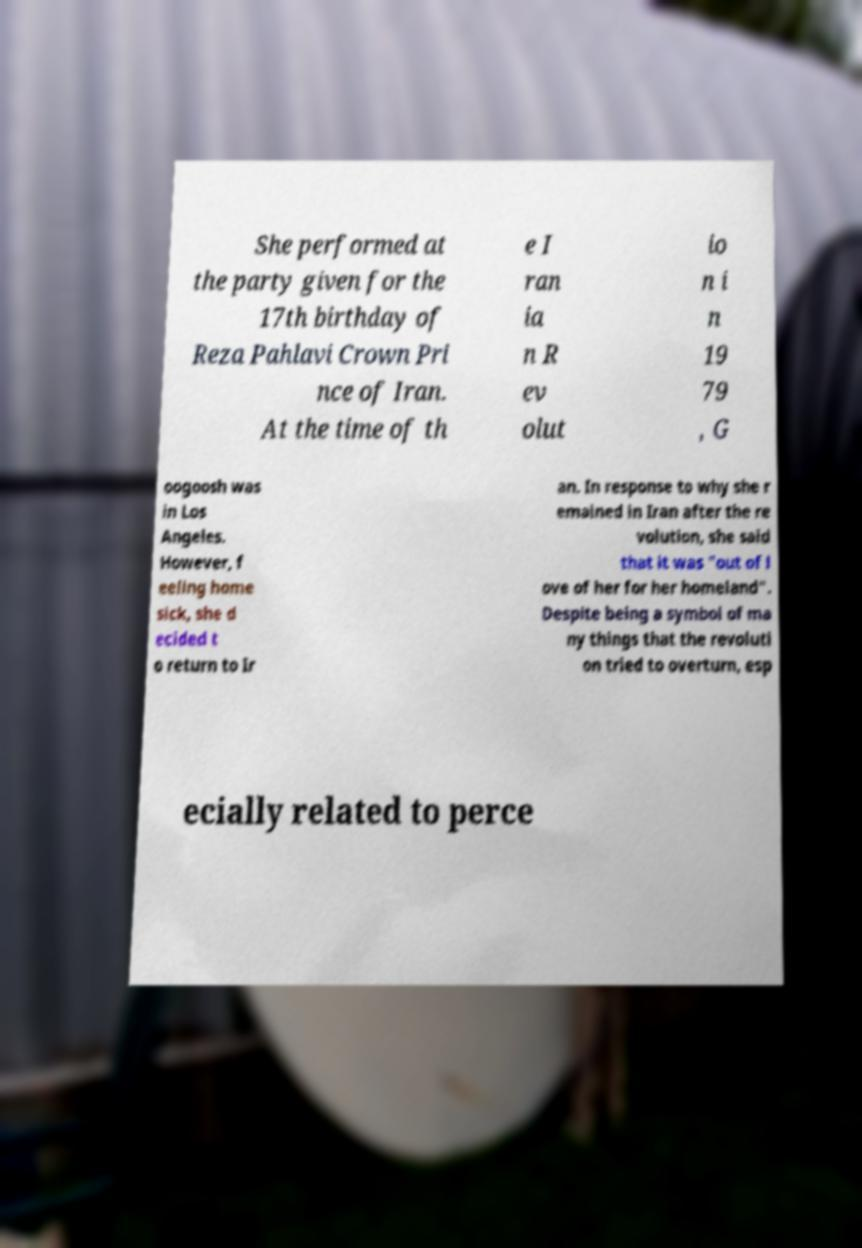I need the written content from this picture converted into text. Can you do that? She performed at the party given for the 17th birthday of Reza Pahlavi Crown Pri nce of Iran. At the time of th e I ran ia n R ev olut io n i n 19 79 , G oogoosh was in Los Angeles. However, f eeling home sick, she d ecided t o return to Ir an. In response to why she r emained in Iran after the re volution, she said that it was "out of l ove of her for her homeland". Despite being a symbol of ma ny things that the revoluti on tried to overturn, esp ecially related to perce 